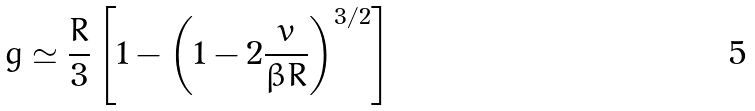<formula> <loc_0><loc_0><loc_500><loc_500>g \simeq \frac { R } { 3 } \left [ 1 - \left ( 1 - 2 \frac { v } { \beta R } \right ) ^ { 3 / 2 } \right ]</formula> 